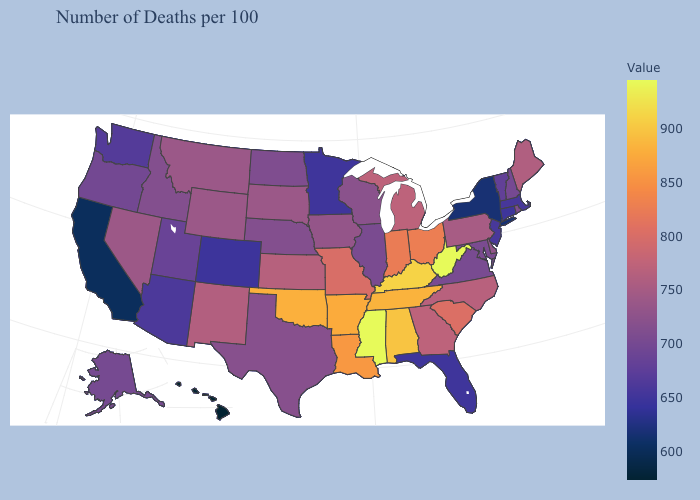Does the map have missing data?
Answer briefly. No. Among the states that border Indiana , which have the highest value?
Short answer required. Kentucky. Does West Virginia have the highest value in the USA?
Write a very short answer. Yes. Does the map have missing data?
Quick response, please. No. Does Iowa have a higher value than West Virginia?
Keep it brief. No. Does Hawaii have the lowest value in the USA?
Concise answer only. Yes. 